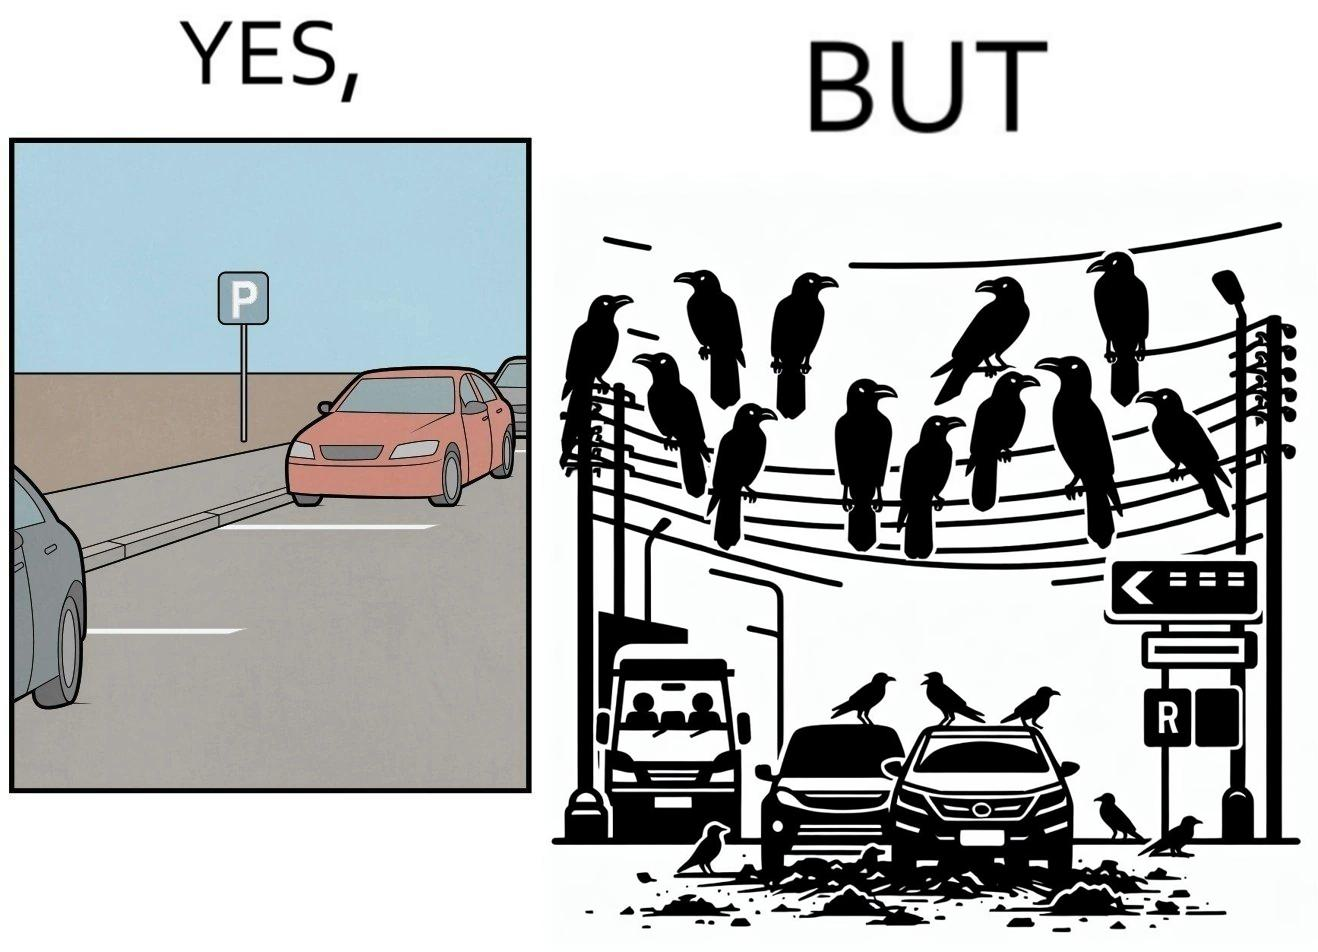Is there satirical content in this image? Yes, this image is satirical. 